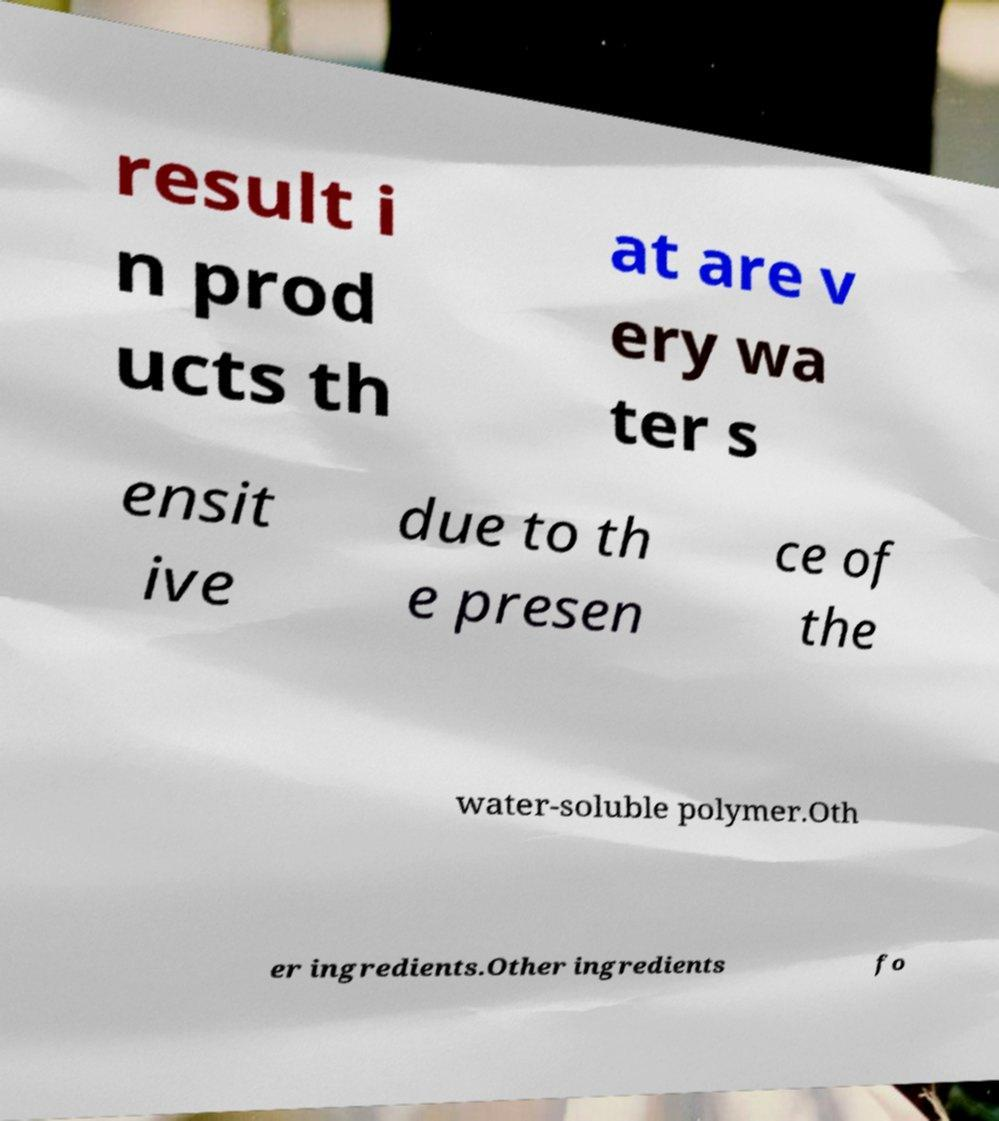Can you read and provide the text displayed in the image?This photo seems to have some interesting text. Can you extract and type it out for me? result i n prod ucts th at are v ery wa ter s ensit ive due to th e presen ce of the water-soluble polymer.Oth er ingredients.Other ingredients fo 